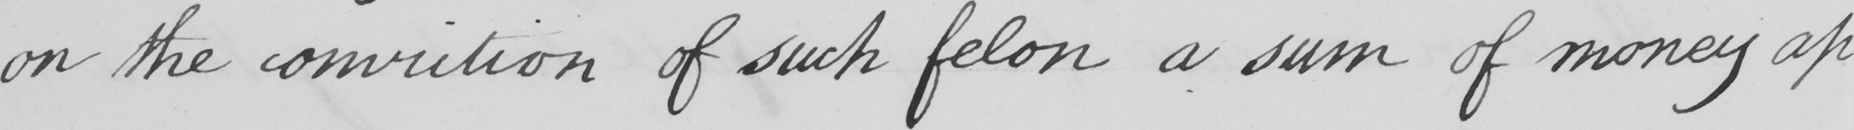Transcribe the text shown in this historical manuscript line. on the conviction of such felon a sum of money ap- 